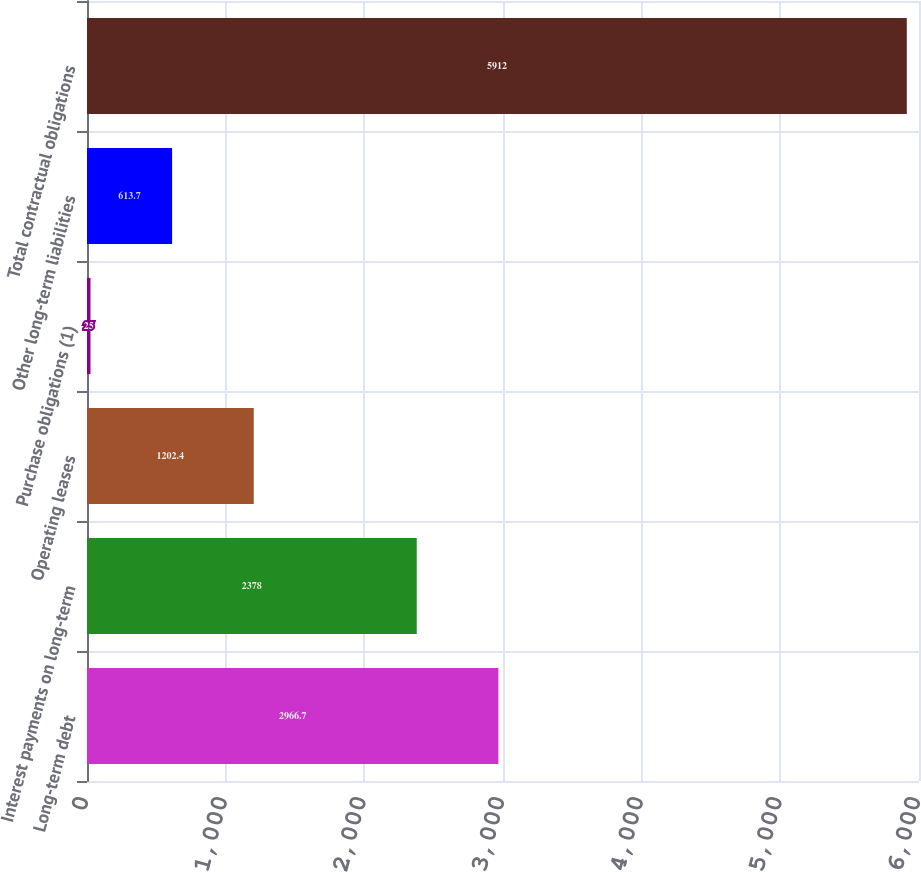Convert chart. <chart><loc_0><loc_0><loc_500><loc_500><bar_chart><fcel>Long-term debt<fcel>Interest payments on long-term<fcel>Operating leases<fcel>Purchase obligations (1)<fcel>Other long-term liabilities<fcel>Total contractual obligations<nl><fcel>2966.7<fcel>2378<fcel>1202.4<fcel>25<fcel>613.7<fcel>5912<nl></chart> 